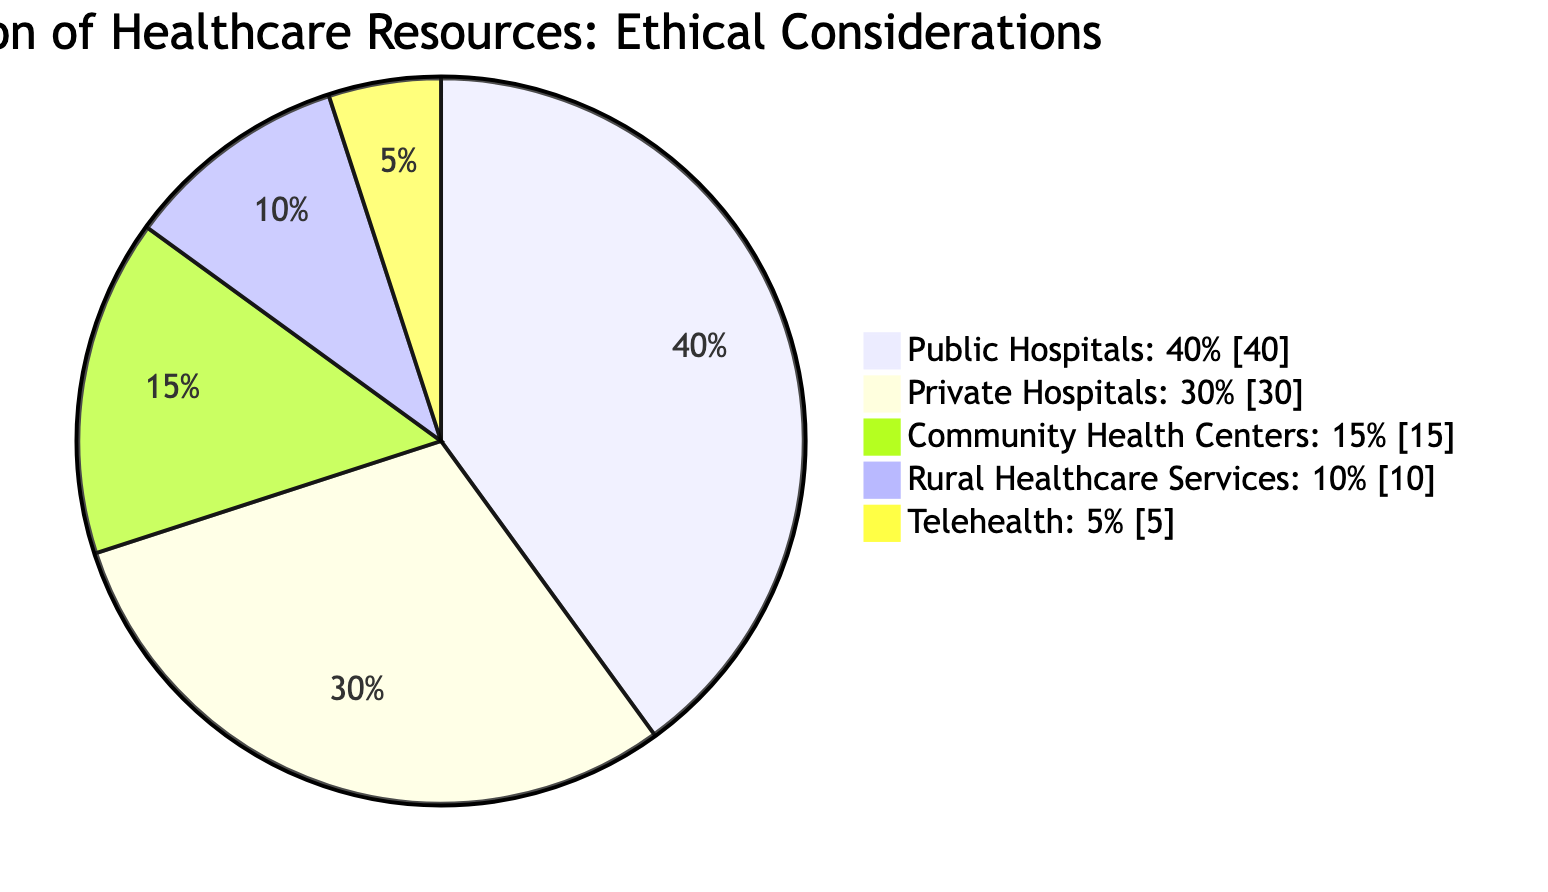What percentage of healthcare resources is allocated to public hospitals? The diagram specifically states that 40% of healthcare resources are allocated to public hospitals. This percentage is clearly labeled in the pie chart.
Answer: 40% What is the combined percentage of resources allocated to private hospitals and community health centers? To find the combined percentage, we add the allocations for private hospitals (30%) and community health centers (15%). Therefore, 30 + 15 equals 45.
Answer: 45% Which category has the least allocation of resources? The diagram indicates that telehealth has the least percentage of allocation at 5%. This is the smallest slice in the pie chart compared to other categories.
Answer: Telehealth What is the ratio of resources allocated to rural healthcare services compared to community health centers? The allocation for rural healthcare services is 10%, while community health centers have 15%. To find the ratio, we can express them as a fraction: 10 to 15 simplifies to 2 to 3.
Answer: 2 to 3 Does the diagram indicate a prioritization of vulnerable groups in the resource allocation? The allocation favors community health centers and rural healthcare services, which typically serve vulnerable populations. This suggests an ethical consideration for those groups, indicating prioritization.
Answer: Yes How much of the total healthcare resources is dedicated to telehealth and rural healthcare services combined? By adding the allocations for telehealth (5%) and rural healthcare services (10%), we find the total is 5 + 10, which equals 15%. This requires simple addition of the two specified categories.
Answer: 15% Which category accounts for the majority of healthcare resources? Public hospitals account for the largest portion of the pie chart at 40%, surpassing all other categories in resource allocation.
Answer: Public Hospitals What implication does the allocation of resources to community health centers suggest about health equity? The higher allocation to community health centers (15%) implies an effort to promote health equity, as these centers often address the needs of underrepresented populations. This supports ethical practices in prioritizing health access.
Answer: Promotes equity 